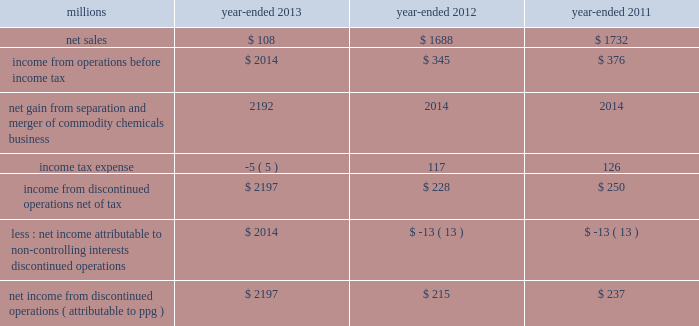74 2013 ppg annual report and form 10-k 22 .
Separation and merger transaction on january 28 , 2013 , the company completed the previously announced separation of its commodity chemicals business and merger of its wholly-owned subsidiary , eagle spinco inc. , with a subsidiary of georgia gulf corporation in a tax ef ficient reverse morris trust transaction ( the 201ctransaction 201d ) .
Pursuant to the merger , eagle spinco , the entity holding ppg's former commodity chemicals business , became a wholly-owned subsidiary of georgia gulf .
The closing of the merger followed the expiration of the related exchange offer and the satisfaction of certain other conditions .
The combined company formed by uniting georgia gulf with ppg's former commodity chemicals business is named axiall corporation ( 201caxiall 201d ) .
Ppg holds no ownership interest in axiall .
Ppg received the necessary ruling from the internal revenue service and as a result this transaction was generally tax free to ppg and its shareholders in the united states and canada .
Under the terms of the exchange offer , 35249104 shares of eagle spinco common stock were available for distribution in exchange for shares of ppg common stock accepted in the offer .
Following the merger , each share of eagle spinco common stock automatically converted into the right to receive one share of axiall corporation common stock .
Accordingly , ppg shareholders who tendered their shares of ppg common stock as part of this offer received 3.2562 shares of axiall common stock for each share of ppg common stock accepted for exchange .
Ppg was able to accept the maximum of 10825227 shares of ppg common stock for exchange in the offer , and thereby , reduced its outstanding shares by approximately 7% ( 7 % ) .
The completion of this exchange offer was a non-cash financing transaction , which resulted in an increase in "treasury stock" at a cost of $ 1.561 billion based on the ppg closing stock price on january 25 , 2013 .
Under the terms of the transaction , ppg received $ 900 million of cash and 35.2 million shares of axiall common stock ( market value of $ 1.8 billion on january 25 , 2013 ) which was distributed to ppg shareholders by the exchange offer as described above .
In addition , ppg received $ 67 million in cash for a preliminary post-closing working capital adjustment under the terms of the transaction agreements .
The net assets transferred to axiall included $ 27 million of cash on the books of the business transferred .
In the transaction , ppg transferred environmental remediation liabilities , defined benefit pension plan assets and liabilities and other post-employment benefit liabilities related to the commodity chemicals business to axiall .
During the first quarter of 2013 , ppg recorded a gain of $ 2.2 billion on the transaction reflecting the excess of the sum of the cash proceeds received and the cost ( closing stock price on january 25 , 2013 ) of the ppg shares tendered and accepted in the exchange for the 35.2 million shares of axiall common stock over the net book value of the net assets of ppg's former commodity chemicals business .
The transaction resulted in a net partial settlement loss of $ 33 million associated with the spin out and termination of defined benefit pension liabilities and the transfer of other post-retirement benefit liabilities under the terms of the transaction .
The company also incurred $ 14 million of pretax expense , primarily for professional services related to the transaction in 2013 as well as approximately $ 2 million of net expense related to certain retained obligations and post-closing adjustments under the terms of the transaction agreements .
The net gain on the transaction includes these related losses and expenses .
The results of operations and cash flows of ppg's former commodity chemicals business for january 2013 and the net gain on the transaction are reported as results from discontinued operations for the year -ended december 31 , 2013 .
In prior periods presented , the results of operations and cash flows of ppg's former commodity chemicals business have been reclassified from continuing operations and presented as results from discontinued operations .
Ppg will provide axiall with certain transition services for up to 24 months following the closing date of the transaction .
These services include logistics , purchasing , finance , information technology , human resources , tax and payroll processing .
The net sales and income before income taxes of the commodity chemicals business that have been reclassified and reported as discontinued operations are presented in the table below: .
Income from discontinued operations , net of tax $ 2197 $ 228 $ 250 less : net income attributable to non- controlling interests , discontinued operations $ 2014 $ ( 13 ) $ ( 13 ) net income from discontinued operations ( attributable to ppg ) $ 2197 $ 215 $ 237 during 2012 , $ 21 million of business separation costs are included within "income from discontinued operations , net." notes to the consolidated financial statements .
During 2013 , what was the decline in net sales in disco? 
Computations: ((108 - 1688) / 1688)
Answer: -0.93602. 